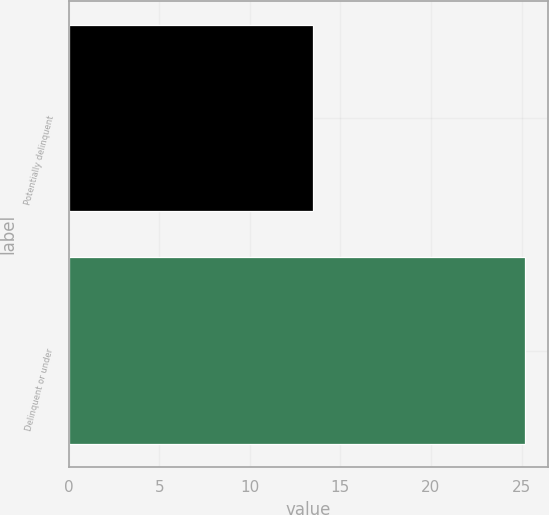Convert chart to OTSL. <chart><loc_0><loc_0><loc_500><loc_500><bar_chart><fcel>Potentially delinquent<fcel>Delinquent or under<nl><fcel>13.5<fcel>25.2<nl></chart> 